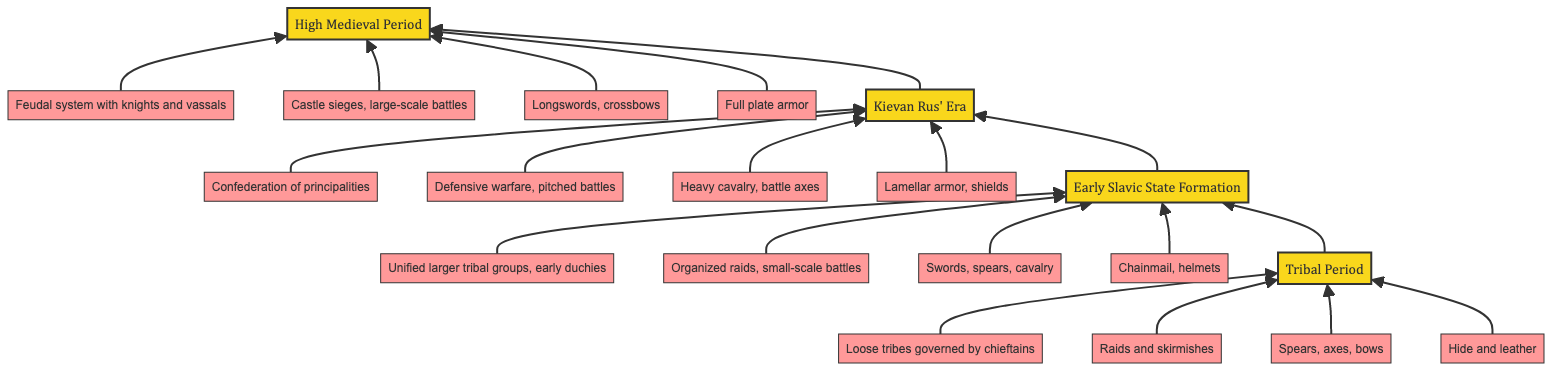What is the topmost period in the diagram? The topmost period in the diagram is represented by the highest node, which is "High Medieval Period".
Answer: High Medieval Period How many main periods are presented in the diagram? The diagram contains four main periods: Tribal Period, Early Slavic State Formation, Kievan Rus' Era, and High Medieval Period. Counting these nodes gives us a total of four periods.
Answer: 4 What is the combat style for the Kievan Rus' Era? In the node representing the Kievan Rus' Era, the combat style is listed as "Defensive warfare, pitched battles".
Answer: Defensive warfare, pitched battles Which weapon is associated with the Early Slavic State Formation? Observing the "Early Slavic State Formation" node, the associated weapon is "Swords, spears, cavalry".
Answer: Swords, spears, cavalry What organizational structure is described in the High Medieval Period? The High Medieval Period node describes the organizational structure as "Feudal system with knights and vassals".
Answer: Feudal system with knights and vassals How does the combat style evolve from the Tribal Period to the High Medieval Period? To determine the evolution of combat styles, we evaluate the nodes starting from "Raids and skirmishes" in the Tribal Period, moving to "Castle sieges, large-scale battles" in the High Medieval Period. This shows that combat tactics evolved from small-scale engagements to larger, more organized warfare methods.
Answer: Evolved from raids to sieges Which armor type was used during the Kievan Rus' Era? By looking at the Kievan Rus' Era node, the listed armor type is "Lamellar armor, shields".
Answer: Lamellar armor, shields What is the relationship between the Early Slavic State Formation and the Tribal Period? The relationship is a progression; the Early Slavic State Formation, represented as the second node, follows directly from the Tribal Period, indicating an evolution in military organization and tactics.
Answer: Progression What kind of warfare is characteristic of the High Medieval Period? In the High Medieval Period node, the characteristic warfare is defined as "Castle sieges, large-scale battles", indicating a shift to more complex military operations.
Answer: Castle sieges, large-scale battles 